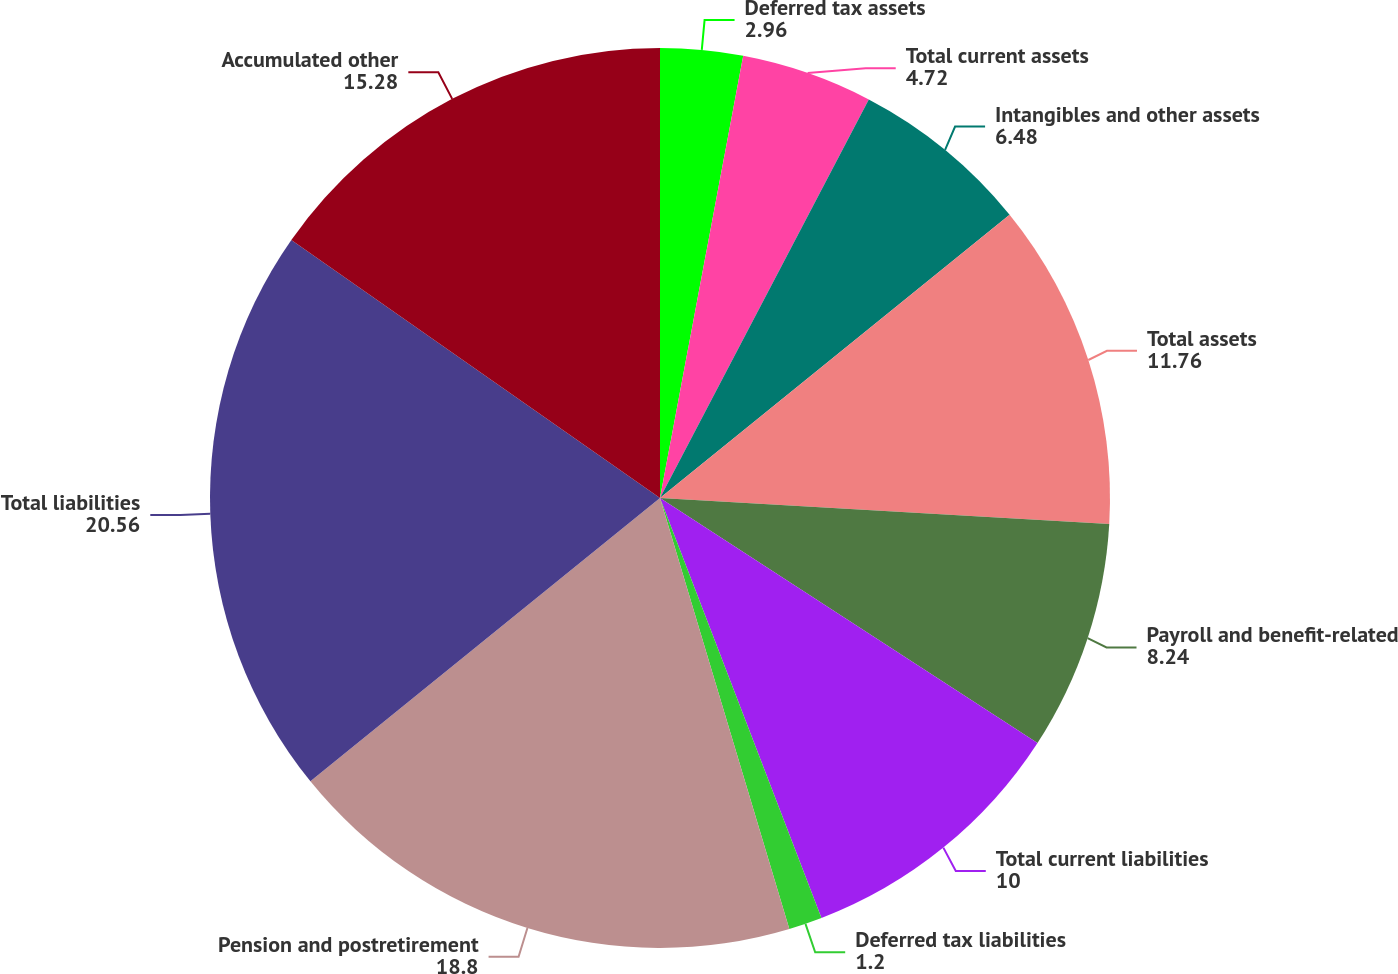Convert chart to OTSL. <chart><loc_0><loc_0><loc_500><loc_500><pie_chart><fcel>Deferred tax assets<fcel>Total current assets<fcel>Intangibles and other assets<fcel>Total assets<fcel>Payroll and benefit-related<fcel>Total current liabilities<fcel>Deferred tax liabilities<fcel>Pension and postretirement<fcel>Total liabilities<fcel>Accumulated other<nl><fcel>2.96%<fcel>4.72%<fcel>6.48%<fcel>11.76%<fcel>8.24%<fcel>10.0%<fcel>1.2%<fcel>18.8%<fcel>20.56%<fcel>15.28%<nl></chart> 